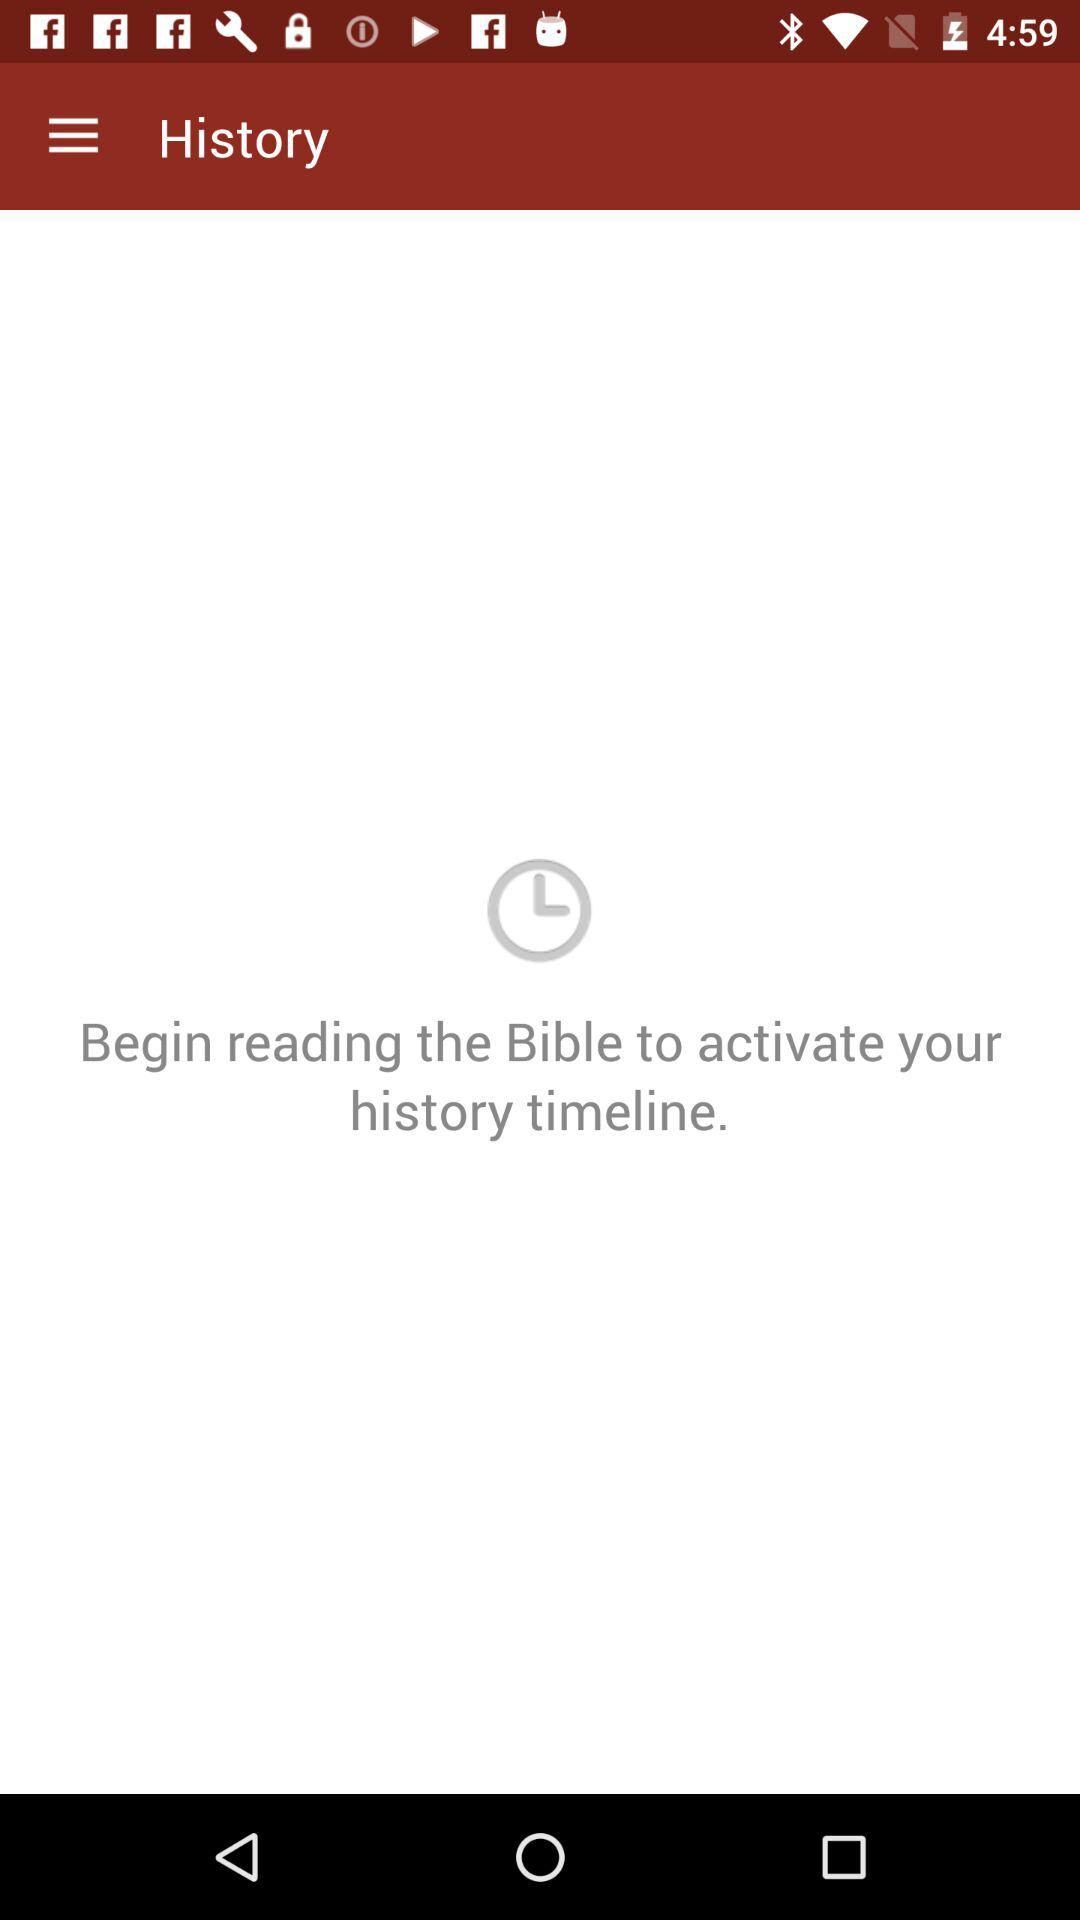Which version of the Bible is being read?
When the provided information is insufficient, respond with <no answer>. <no answer> 